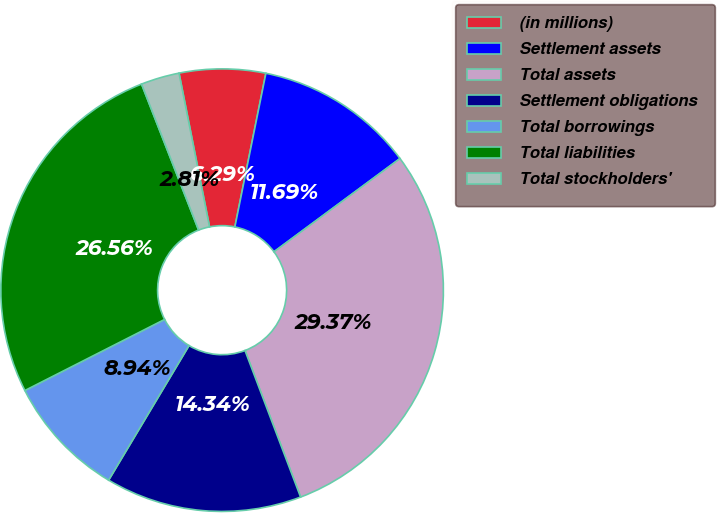<chart> <loc_0><loc_0><loc_500><loc_500><pie_chart><fcel>(in millions)<fcel>Settlement assets<fcel>Total assets<fcel>Settlement obligations<fcel>Total borrowings<fcel>Total liabilities<fcel>Total stockholders'<nl><fcel>6.29%<fcel>11.69%<fcel>29.37%<fcel>14.34%<fcel>8.94%<fcel>26.56%<fcel>2.81%<nl></chart> 